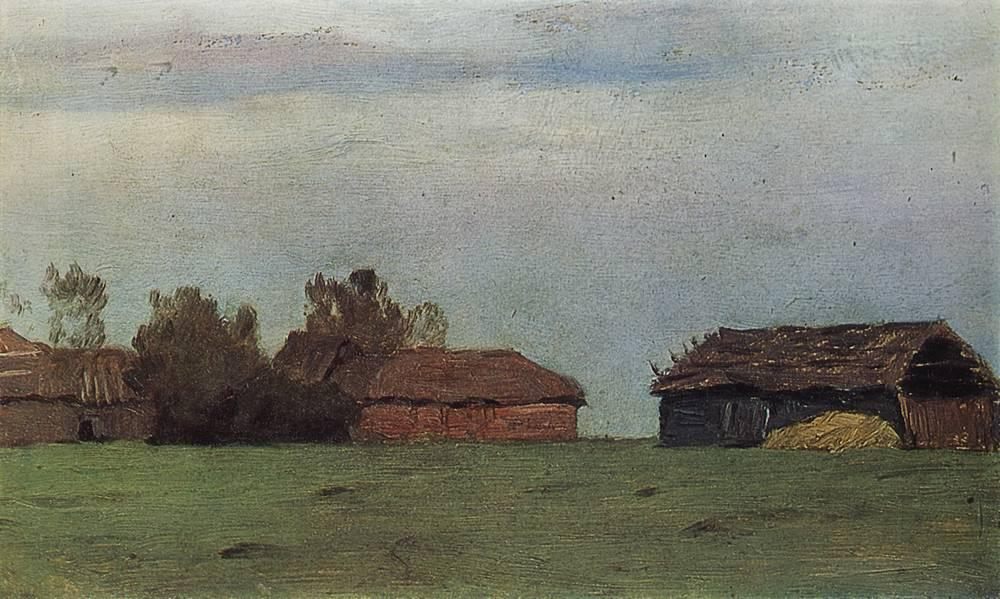What's happening in the scene? The image depicts a rural landscape featuring an array of farm structures in varying states of decay. These wooden buildings, with their weathered surfaces and sagging roofs, tell a story of aging and neglect amidst a sprawling field. The scene is cast under a soft, broad daylight that washes over the sparse grass and the sky above, painted with gentle strokes of blue and scattered clouds. This artwork captures a tranquil, albeit somber, atmosphere that reflects themes of time's impact on man-made structures and the enduring, quiet resilience of nature. 